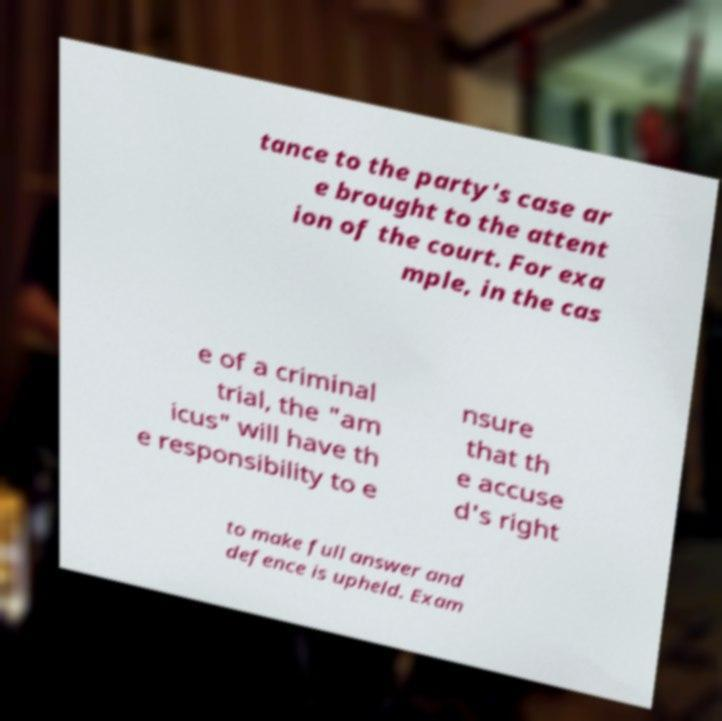Please read and relay the text visible in this image. What does it say? tance to the party's case ar e brought to the attent ion of the court. For exa mple, in the cas e of a criminal trial, the "am icus" will have th e responsibility to e nsure that th e accuse d's right to make full answer and defence is upheld. Exam 